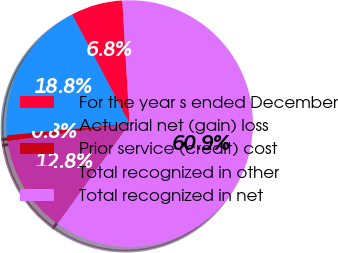<chart> <loc_0><loc_0><loc_500><loc_500><pie_chart><fcel>For the year s ended December<fcel>Actuarial net (gain) loss<fcel>Prior service (credit) cost<fcel>Total recognized in other<fcel>Total recognized in net<nl><fcel>6.78%<fcel>18.8%<fcel>0.77%<fcel>12.79%<fcel>60.86%<nl></chart> 